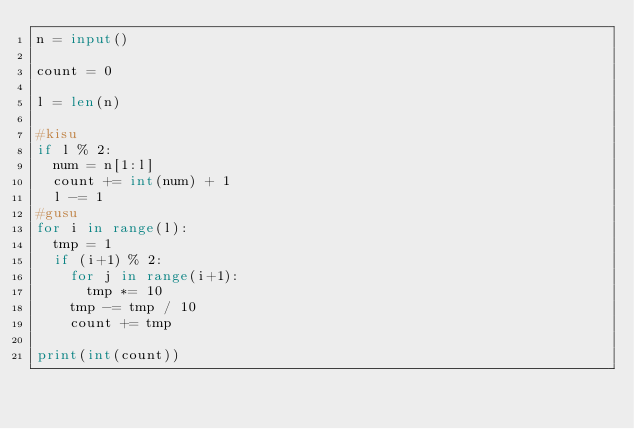<code> <loc_0><loc_0><loc_500><loc_500><_Python_>n = input()

count = 0

l = len(n)

#kisu
if l % 2:
  num = n[1:l]
  count += int(num) + 1
  l -= 1
#gusu
for i in range(l):
  tmp = 1
  if (i+1) % 2:
    for j in range(i+1):
      tmp *= 10
    tmp -= tmp / 10
    count += tmp
    
print(int(count))</code> 